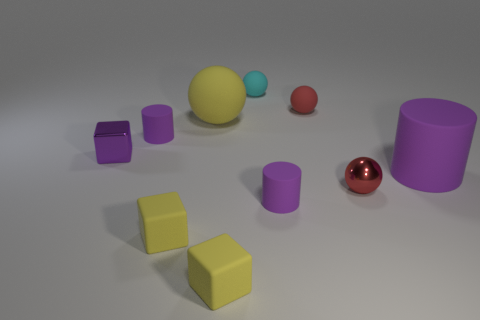How big is the purple matte cylinder that is in front of the red shiny thing?
Provide a short and direct response. Small. What material is the tiny yellow cube that is to the right of the yellow ball behind the big purple cylinder?
Your answer should be very brief. Rubber. There is a small yellow thing left of the yellow matte object behind the purple cube; what number of tiny yellow cubes are in front of it?
Provide a succinct answer. 1. Are the purple thing that is in front of the big purple cylinder and the cylinder on the right side of the tiny metallic ball made of the same material?
Give a very brief answer. Yes. What material is the block that is the same color as the big cylinder?
Ensure brevity in your answer.  Metal. How many tiny red matte objects are the same shape as the small red metal thing?
Offer a terse response. 1. Is the number of big purple rubber objects right of the red metal thing greater than the number of tiny matte spheres?
Your answer should be compact. No. The small thing in front of the small yellow matte cube behind the small yellow rubber block that is right of the large yellow sphere is what shape?
Provide a short and direct response. Cube. There is a metallic thing that is on the left side of the tiny cyan matte thing; is its shape the same as the matte object that is to the right of the tiny red rubber sphere?
Offer a very short reply. No. How many spheres are either purple objects or small red metallic objects?
Offer a terse response. 1. 